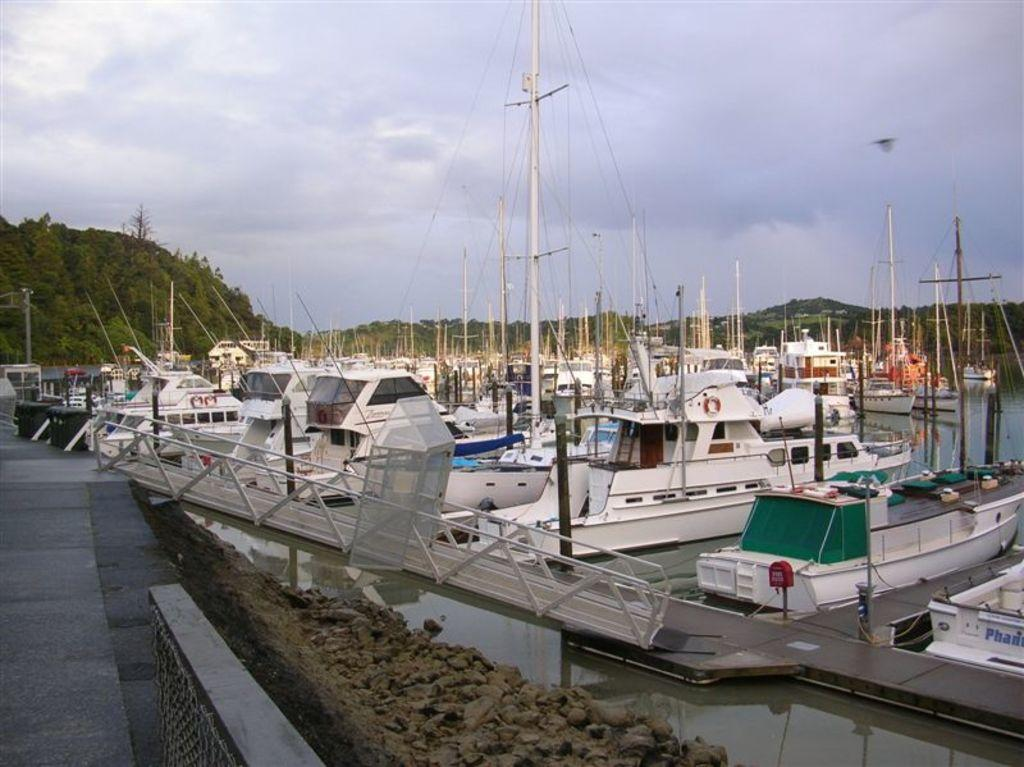What structure is located on the left side of the image? There is a platform on the left side of the image. What can be seen in the water on the right side of the image? There are boats parked in the water on the right side of the image. What type of natural features are visible in the background of the image? There are mountains in the background of the image. What else can be seen in the sky in the background of the image? There are clouds in the sky in the background of the image. What type of achiever is standing on the platform in the image? There is no achiever present in the image; it only features a platform, boats, mountains, and clouds. What show is being performed on the boats in the image? There is no show being performed on the boats in the image; they are parked in the water. 